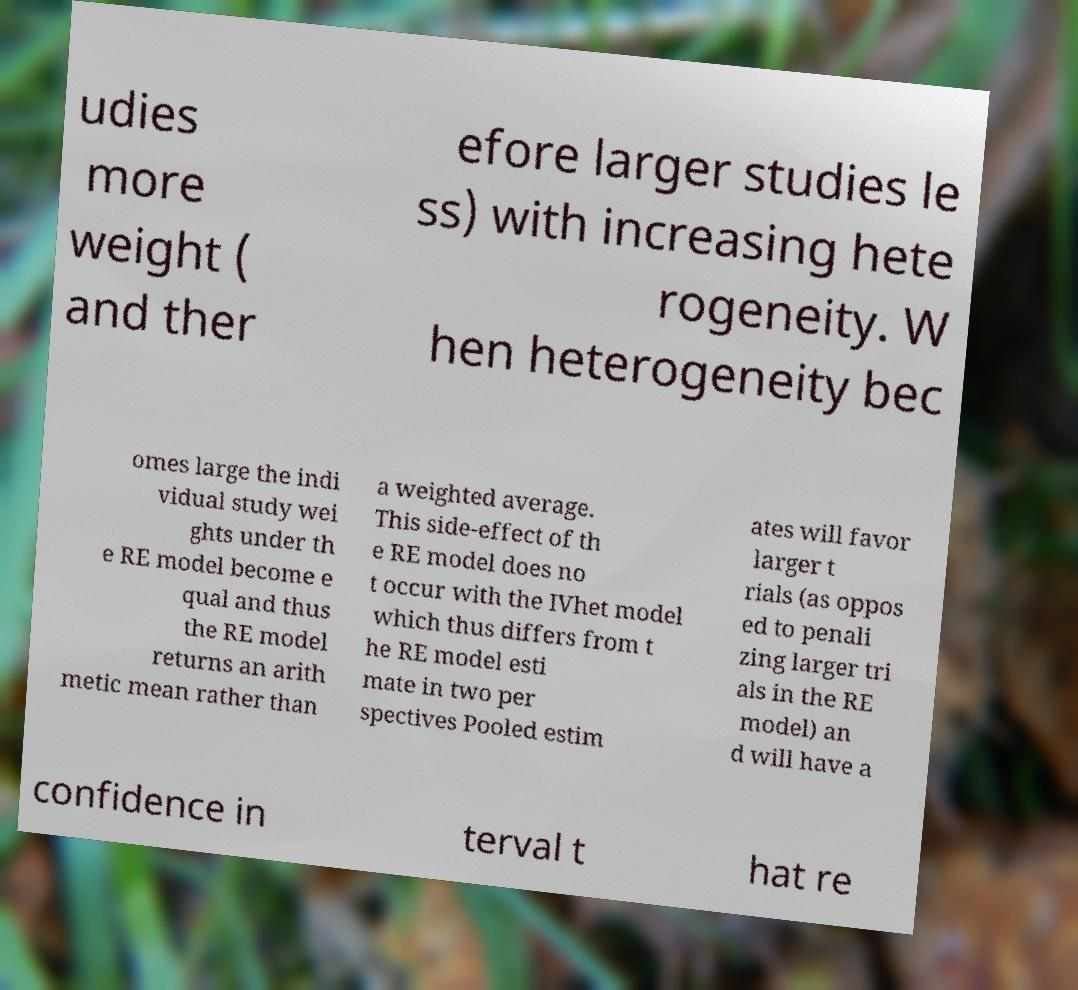Can you accurately transcribe the text from the provided image for me? udies more weight ( and ther efore larger studies le ss) with increasing hete rogeneity. W hen heterogeneity bec omes large the indi vidual study wei ghts under th e RE model become e qual and thus the RE model returns an arith metic mean rather than a weighted average. This side-effect of th e RE model does no t occur with the IVhet model which thus differs from t he RE model esti mate in two per spectives Pooled estim ates will favor larger t rials (as oppos ed to penali zing larger tri als in the RE model) an d will have a confidence in terval t hat re 